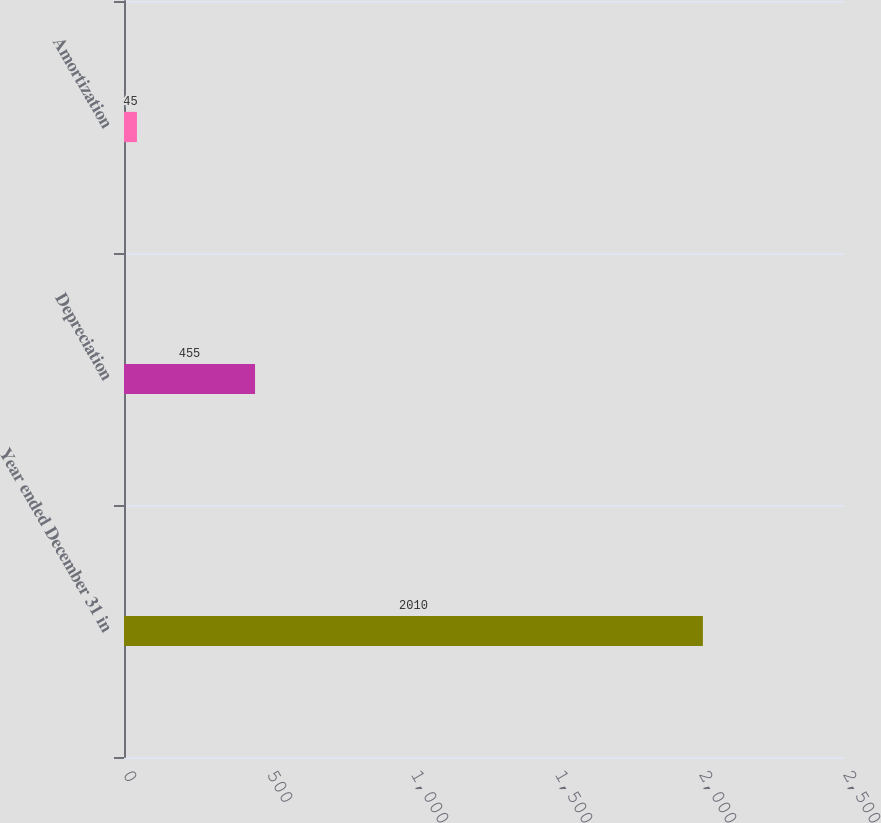<chart> <loc_0><loc_0><loc_500><loc_500><bar_chart><fcel>Year ended December 31 in<fcel>Depreciation<fcel>Amortization<nl><fcel>2010<fcel>455<fcel>45<nl></chart> 